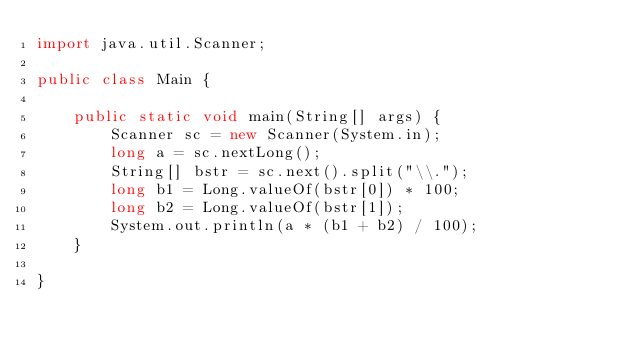<code> <loc_0><loc_0><loc_500><loc_500><_Java_>import java.util.Scanner;

public class Main {

    public static void main(String[] args) {
        Scanner sc = new Scanner(System.in);
        long a = sc.nextLong();
        String[] bstr = sc.next().split("\\.");
        long b1 = Long.valueOf(bstr[0]) * 100;
        long b2 = Long.valueOf(bstr[1]);
        System.out.println(a * (b1 + b2) / 100);
    }

}
</code> 